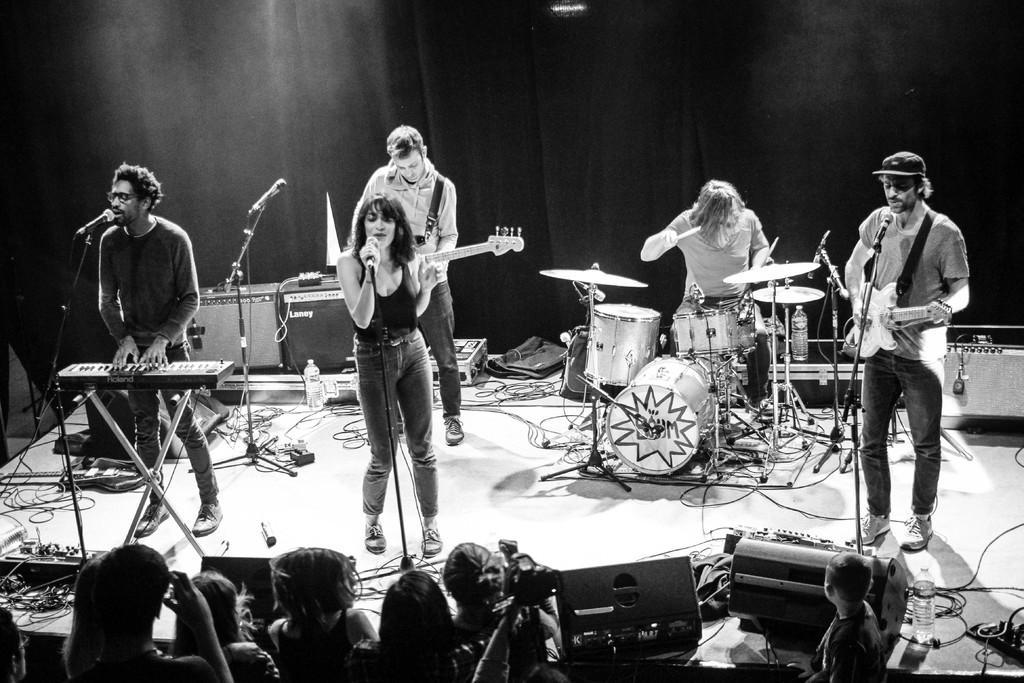Describe this image in one or two sentences. In this image we can see black and white picture of a group of people standing on the stage. One woman is holding a microphone in his hand. Two persons are holding guitars in their hands. In the background, we can see a group of speaker, bottle, musical instruments, cables are placed on the stage and the curtain. 